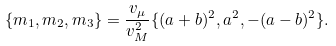<formula> <loc_0><loc_0><loc_500><loc_500>\{ m _ { 1 } , m _ { 2 } , m _ { 3 } \} = \frac { v _ { \mu } } { v _ { M } ^ { 2 } } \{ ( a + b ) ^ { 2 } , a ^ { 2 } , - ( a - b ) ^ { 2 } \} .</formula> 